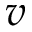Convert formula to latex. <formula><loc_0><loc_0><loc_500><loc_500>v</formula> 